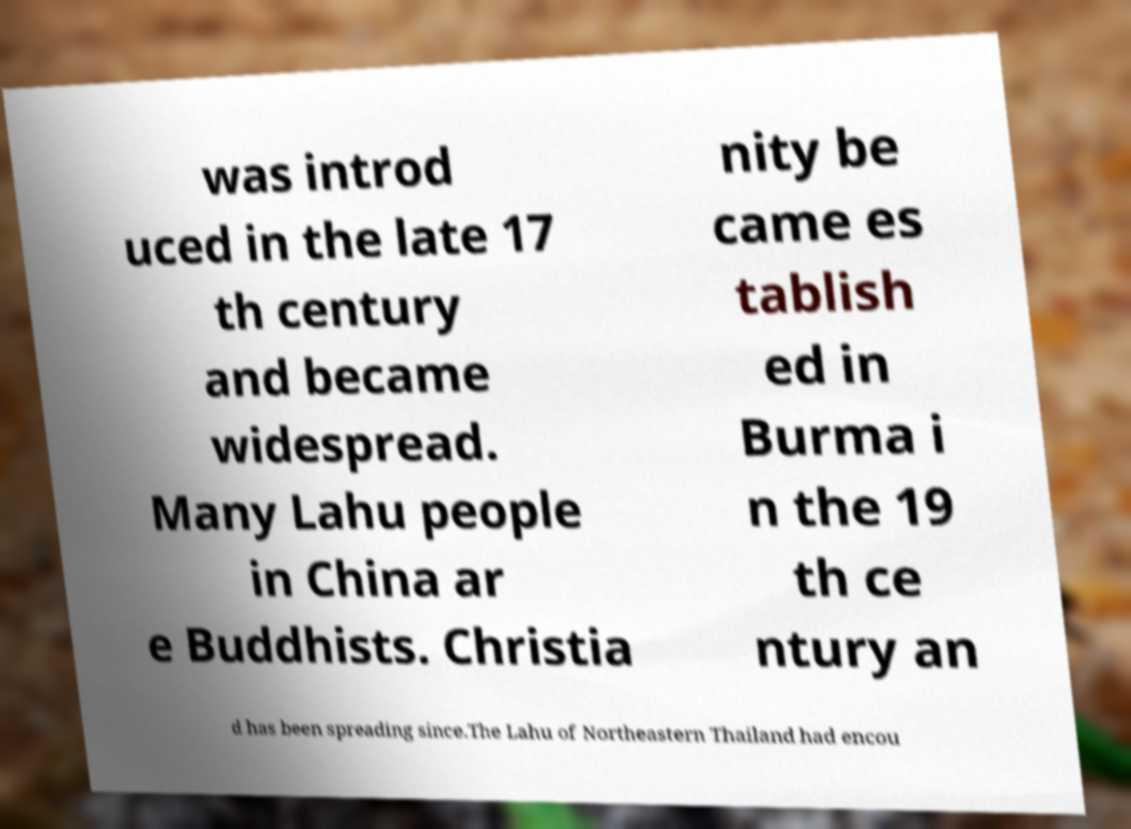What messages or text are displayed in this image? I need them in a readable, typed format. was introd uced in the late 17 th century and became widespread. Many Lahu people in China ar e Buddhists. Christia nity be came es tablish ed in Burma i n the 19 th ce ntury an d has been spreading since.The Lahu of Northeastern Thailand had encou 